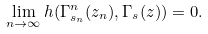Convert formula to latex. <formula><loc_0><loc_0><loc_500><loc_500>\lim _ { n \rightarrow \infty } h ( \Gamma _ { s _ { n } } ^ { n } ( z _ { n } ) , \Gamma _ { s } ( z ) ) = 0 .</formula> 